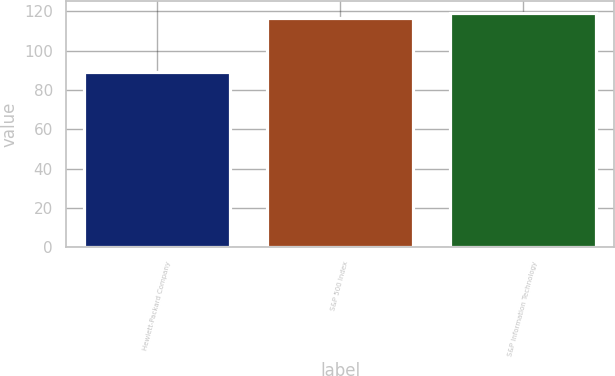<chart> <loc_0><loc_0><loc_500><loc_500><bar_chart><fcel>Hewlett-Packard Company<fcel>S&P 500 Index<fcel>S&P Information Technology<nl><fcel>89.19<fcel>116.51<fcel>119.41<nl></chart> 